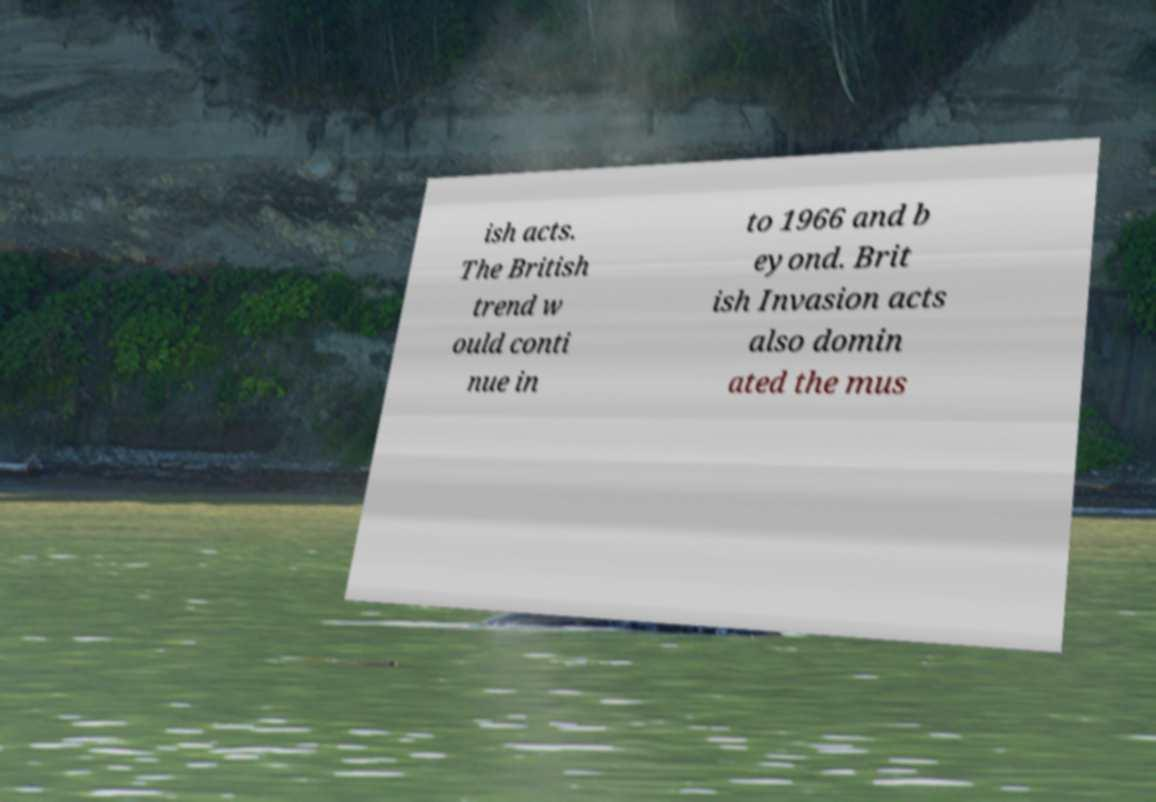Could you extract and type out the text from this image? ish acts. The British trend w ould conti nue in to 1966 and b eyond. Brit ish Invasion acts also domin ated the mus 